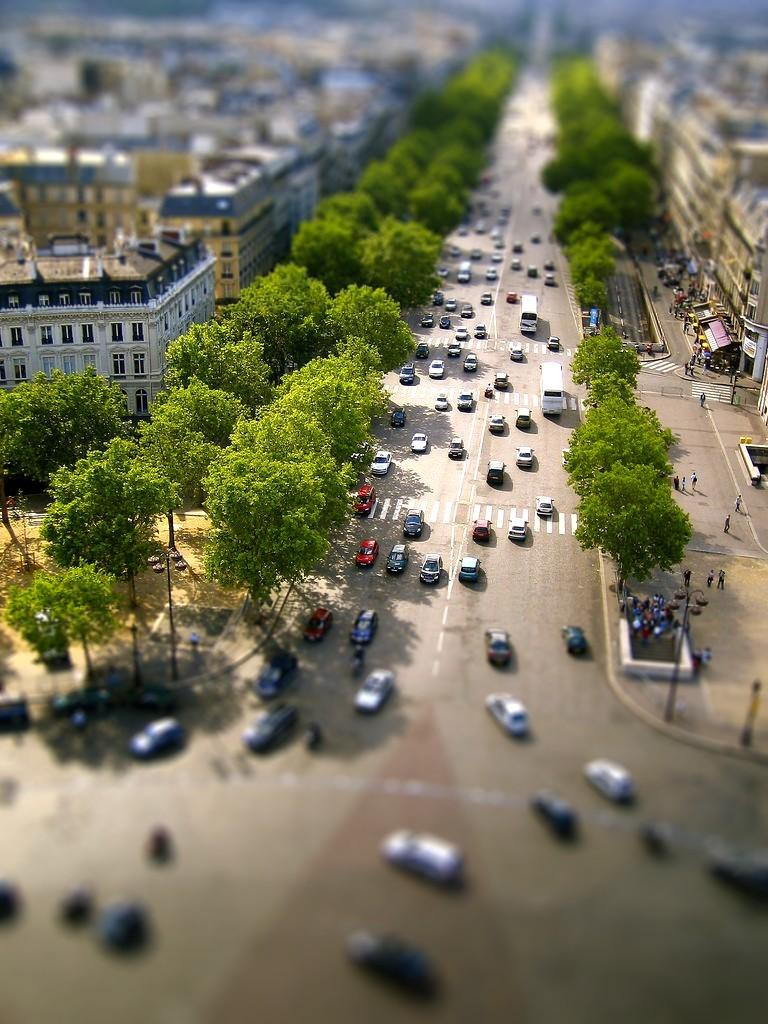What type of structures can be seen in the image? There are buildings in the image. What other natural elements are present in the image? There are trees in the image. What are the people in the image doing? There are people walking in the image. What mode of transportation can be seen in the image? There are vehicles on the road in the image. How would you describe the background of the image? The background of the image is blurred. Can you see any feathers floating in the air in the image? There are no feathers visible in the image. What type of edge can be seen on the buildings in the image? The provided facts do not mention any specific edges on the buildings, so we cannot answer this question definitively. 